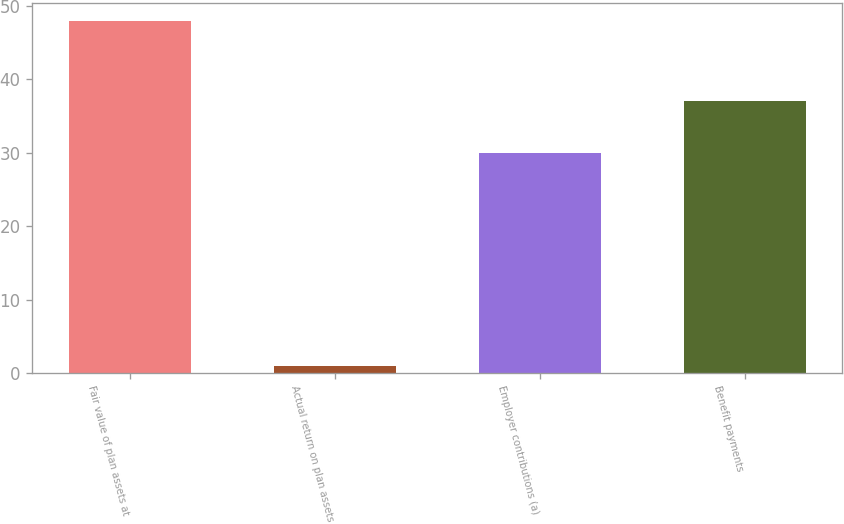Convert chart to OTSL. <chart><loc_0><loc_0><loc_500><loc_500><bar_chart><fcel>Fair value of plan assets at<fcel>Actual return on plan assets<fcel>Employer contributions (a)<fcel>Benefit payments<nl><fcel>48<fcel>1<fcel>30<fcel>37<nl></chart> 